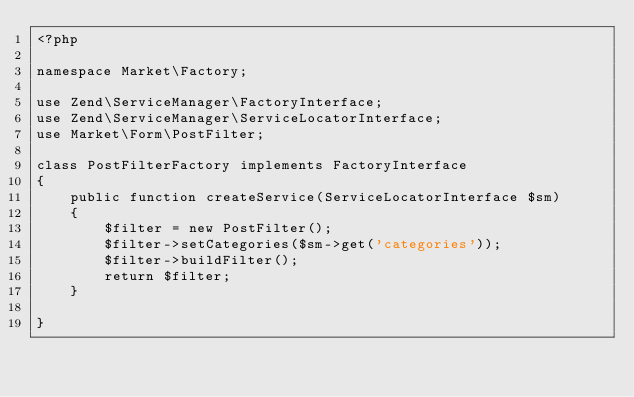Convert code to text. <code><loc_0><loc_0><loc_500><loc_500><_PHP_><?php

namespace Market\Factory;

use Zend\ServiceManager\FactoryInterface;
use Zend\ServiceManager\ServiceLocatorInterface;
use Market\Form\PostFilter;

class PostFilterFactory implements FactoryInterface
{
    public function createService(ServiceLocatorInterface $sm) 
    {
        $filter = new PostFilter();
        $filter->setCategories($sm->get('categories'));
        $filter->buildFilter();
        return $filter;
    }

}
</code> 